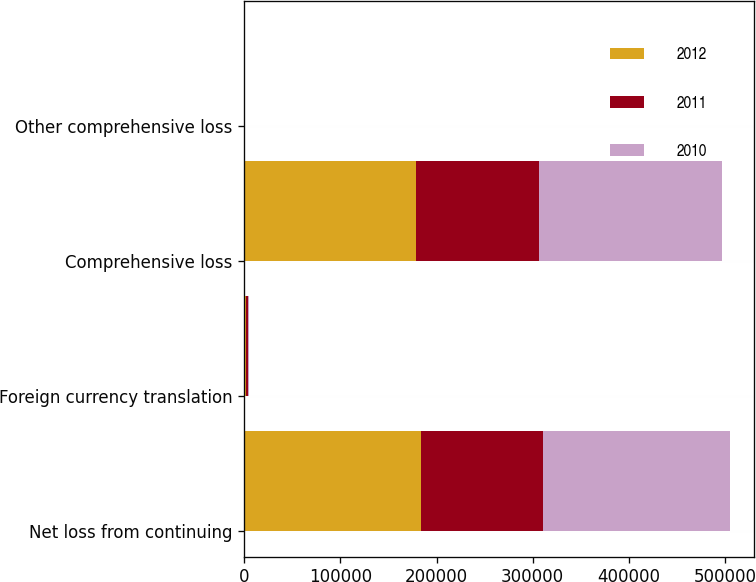Convert chart to OTSL. <chart><loc_0><loc_0><loc_500><loc_500><stacked_bar_chart><ecel><fcel>Net loss from continuing<fcel>Foreign currency translation<fcel>Comprehensive loss<fcel>Other comprehensive loss<nl><fcel>2012<fcel>183686<fcel>2306<fcel>178731<fcel>353<nl><fcel>2011<fcel>126892<fcel>1728<fcel>128184<fcel>436<nl><fcel>2010<fcel>194421<fcel>701<fcel>189741<fcel>298<nl></chart> 